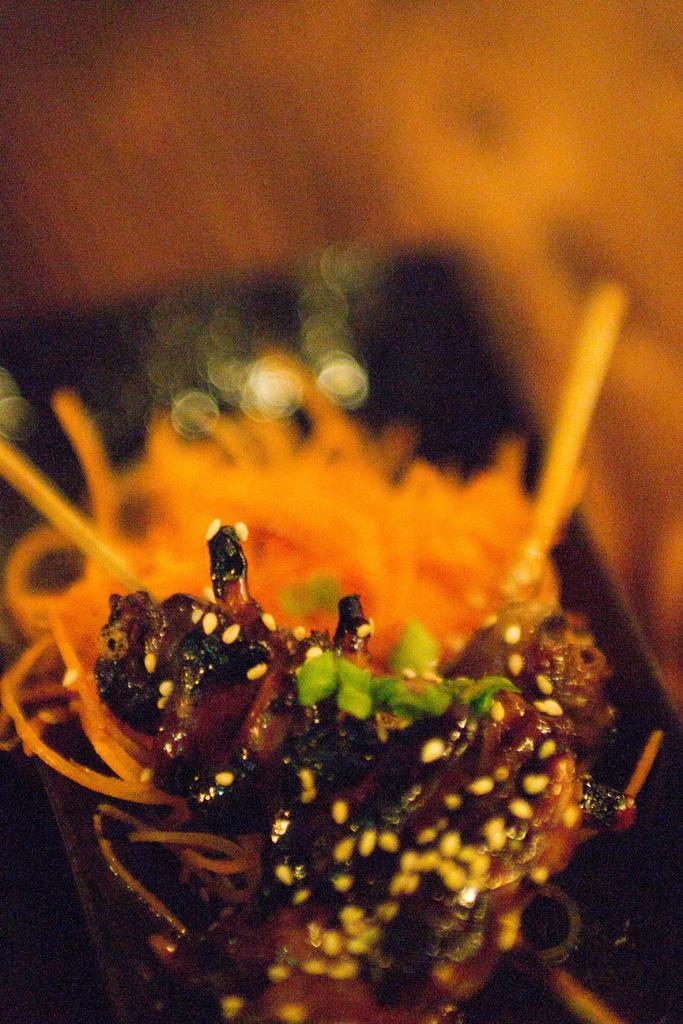Could you give a brief overview of what you see in this image? In this image, in the middle, we can see an insect which is on the flower. In the background, we can see orange color and black color. 